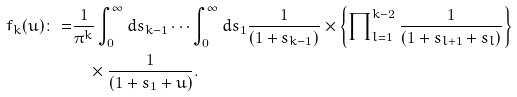Convert formula to latex. <formula><loc_0><loc_0><loc_500><loc_500>f _ { k } ( u ) \colon = & \frac { 1 } { { \pi } ^ { k } } \int _ { 0 } ^ { \infty } d s _ { k - 1 } \cdots \int _ { 0 } ^ { \infty } d s _ { 1 } \frac { 1 } { ( 1 + s _ { k - 1 } ) } \times \left \{ \prod \nolimits _ { l = 1 } ^ { k - 2 } \frac { 1 } { ( 1 + s _ { l + 1 } + s _ { l } ) } \right \} \\ & \quad \times \frac { 1 } { ( 1 + s _ { 1 } + u ) } .</formula> 